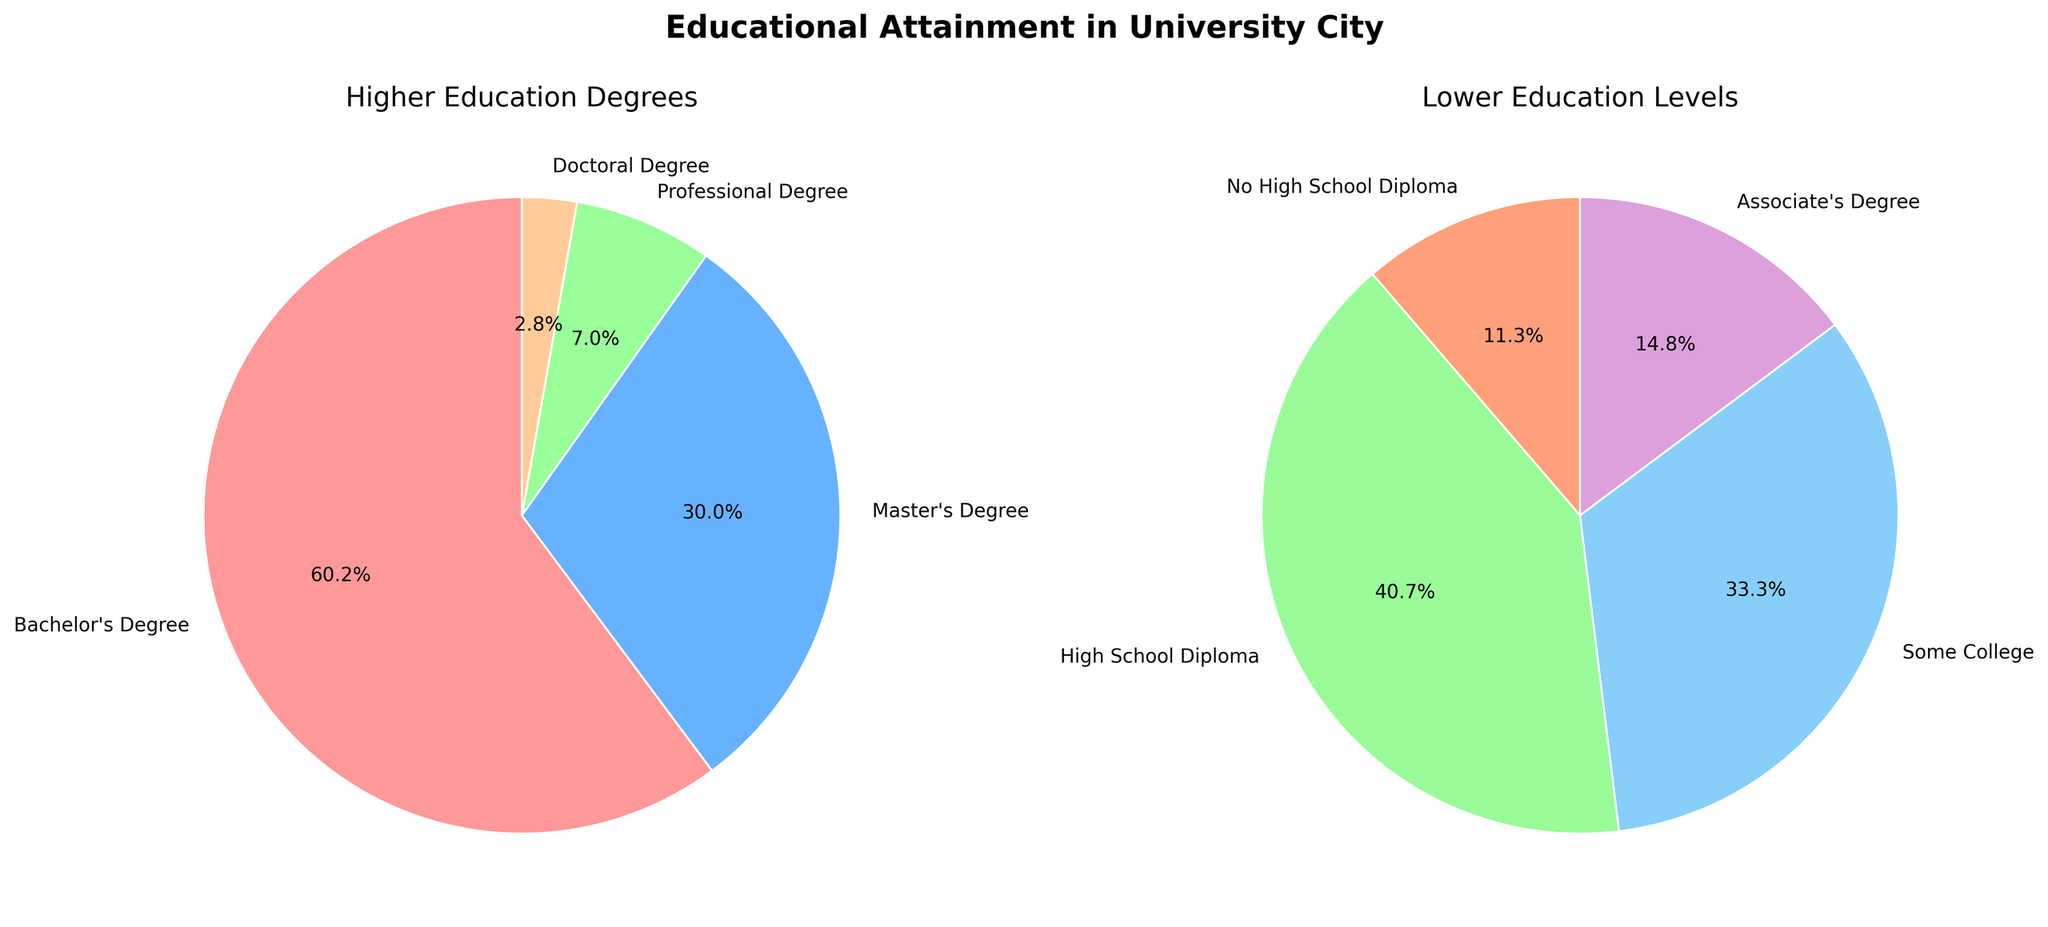What is the percentage of people with a Bachelor's Degree? Check the slice labeled "Bachelor's Degree" on the Higher Education Degrees pie chart. It shows a percentage of 32.5%.
Answer: 32.5% Which educational attainment level has the lowest percentage? Look at both pie charts for the smallest slices. The Doctoral Degree slice in the Higher Education Degrees chart is the smallest at 1.5%.
Answer: Doctoral Degree How does the percentage of people with a Master's Degree compare to those with an Associate's Degree? Find the slices labeled "Master's Degree" and "Associate's Degree" in their respective pie charts. The Master's Degree has a percentage of 16.2%, whereas the Associate's Degree has a percentage of 6.8%. Since 16.2% is greater than 6.8%, more people have a Master's Degree than an Associate's Degree.
Answer: Master's Degree is more What is the combined percentage of people with a High School Diploma and Some College education? Find and sum the percentages for "High School Diploma" and "Some College" in the Lower Education Levels pie chart. High School Diploma is 18.7% and Some College is 15.3%. Adding these together gives 18.7% + 15.3% = 34%.
Answer: 34% Which slice in the Higher Education Degrees pie chart represents the highest percentage and what is it? Inspect the pie chart for Higher Education Degrees. The largest slice belongs to the Bachelor's Degree and represents 32.5%.
Answer: Bachelor's Degree at 32.5% What is the difference in percentage between those without a High School Diploma and those with a Professional Degree? Locate the "No High School Diploma" slice in the Lower Education Levels pie chart (5.2%) and the "Professional Degree" slice in the Higher Education Degrees pie chart (3.8%). Subtract 3.8% from 5.2% to get the difference: 5.2% - 3.8% = 1.4%.
Answer: 1.4% How many degree types are shown in the Higher Education Degrees pie chart? Count the number of slices in the Higher Education Degrees pie chart. There are four slices: Bachelor's Degree, Master's Degree, Professional Degree, and Doctoral Degree.
Answer: 4 What is the total percentage of people who have some form of higher education degree (Bachelor's, Master's, Professional, or Doctoral degrees)? Sum the percentages of all slices in the Higher Education Degrees pie chart: Bachelor's Degree (32.5%), Master's Degree (16.2%), Professional Degree (3.8%), Doctoral Degree (1.5%). Adding these together gives 32.5% + 16.2% + 3.8% + 1.5% = 54%.
Answer: 54% What percentage of people have less than an Associate's Degree? Sum the percentages for "No High School Diploma", "High School Diploma", and "Some College" from the Lower Education Levels pie chart. No High School Diploma is 5.2%, High School Diploma is 18.7%, and Some College is 15.3%. Adding these together gives 5.2% + 18.7% + 15.3% = 39.2%.
Answer: 39.2% What color represents the High School Diploma slice? Look at the color of the slice labeled "High School Diploma" in the Lower Education Levels pie chart. It is represented in green.
Answer: Green 